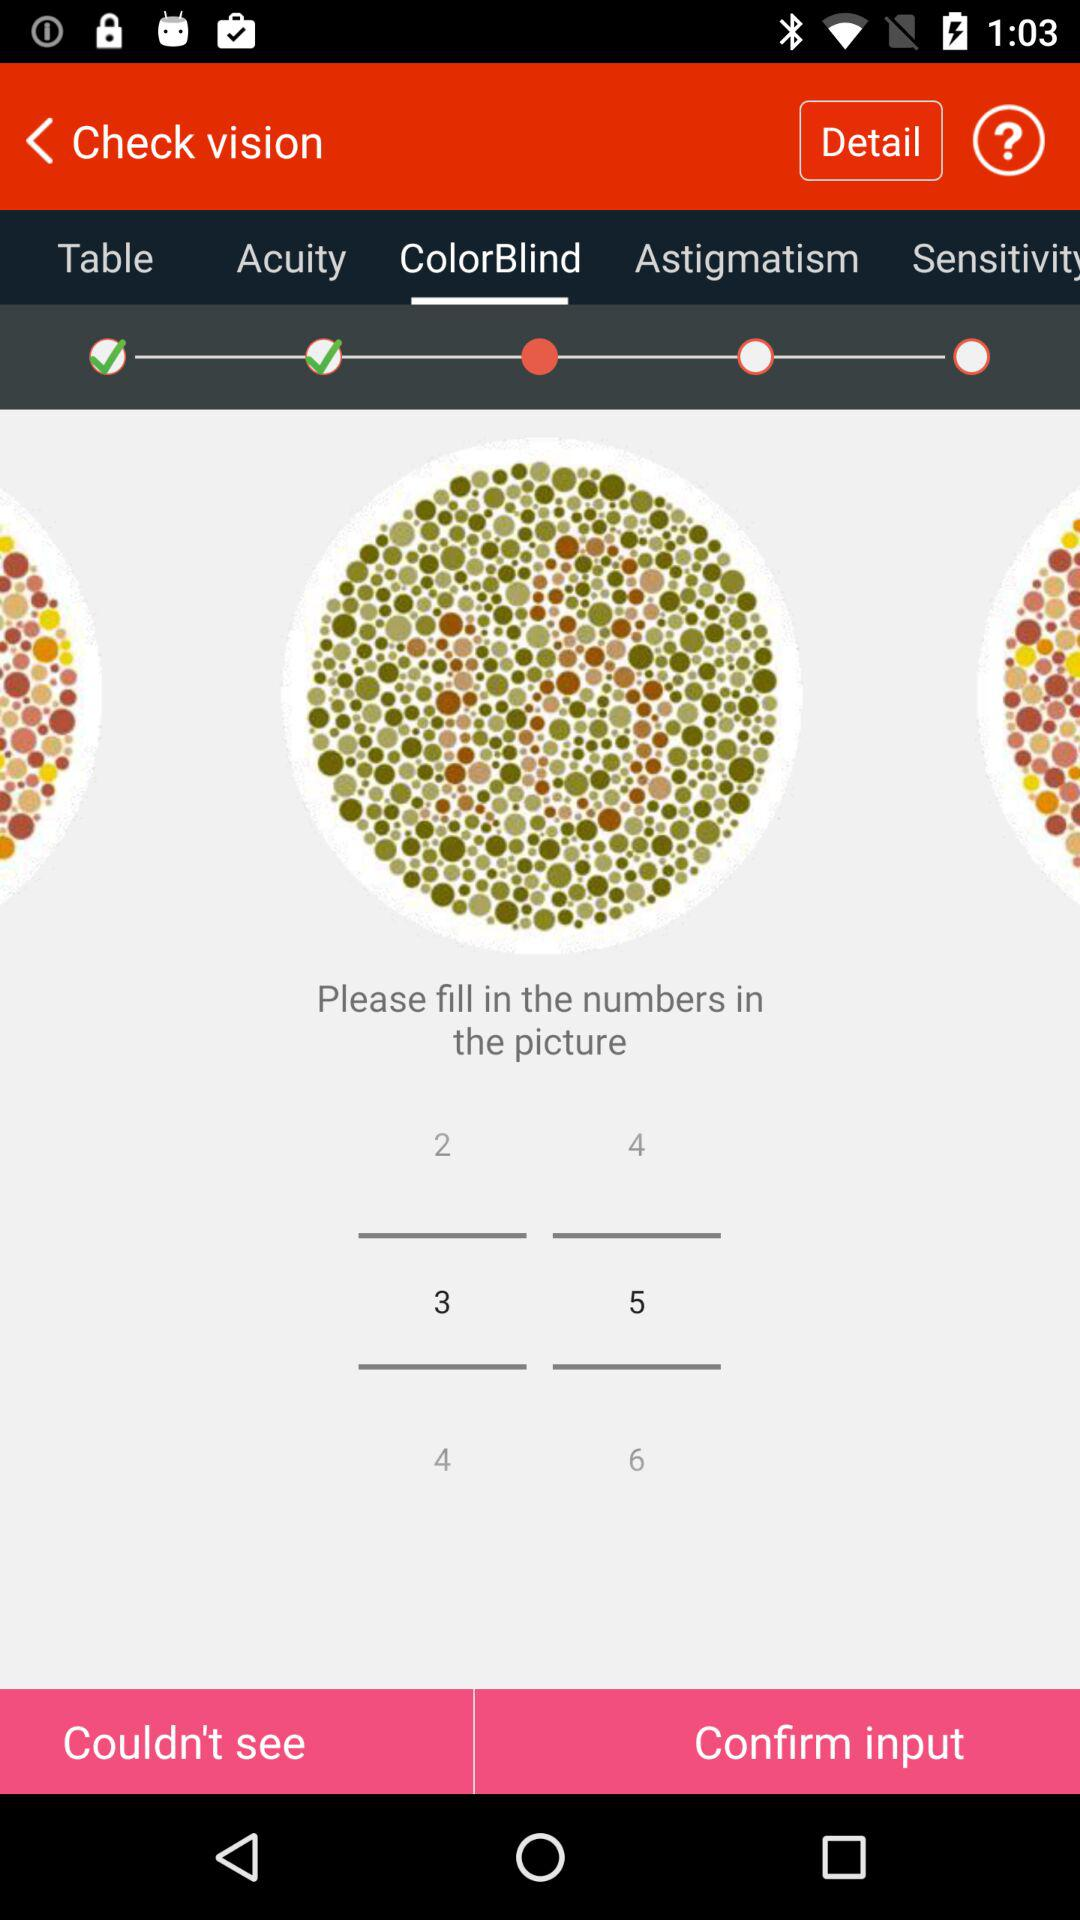Which tab is selected? The selected tab is "ColorBlind". 